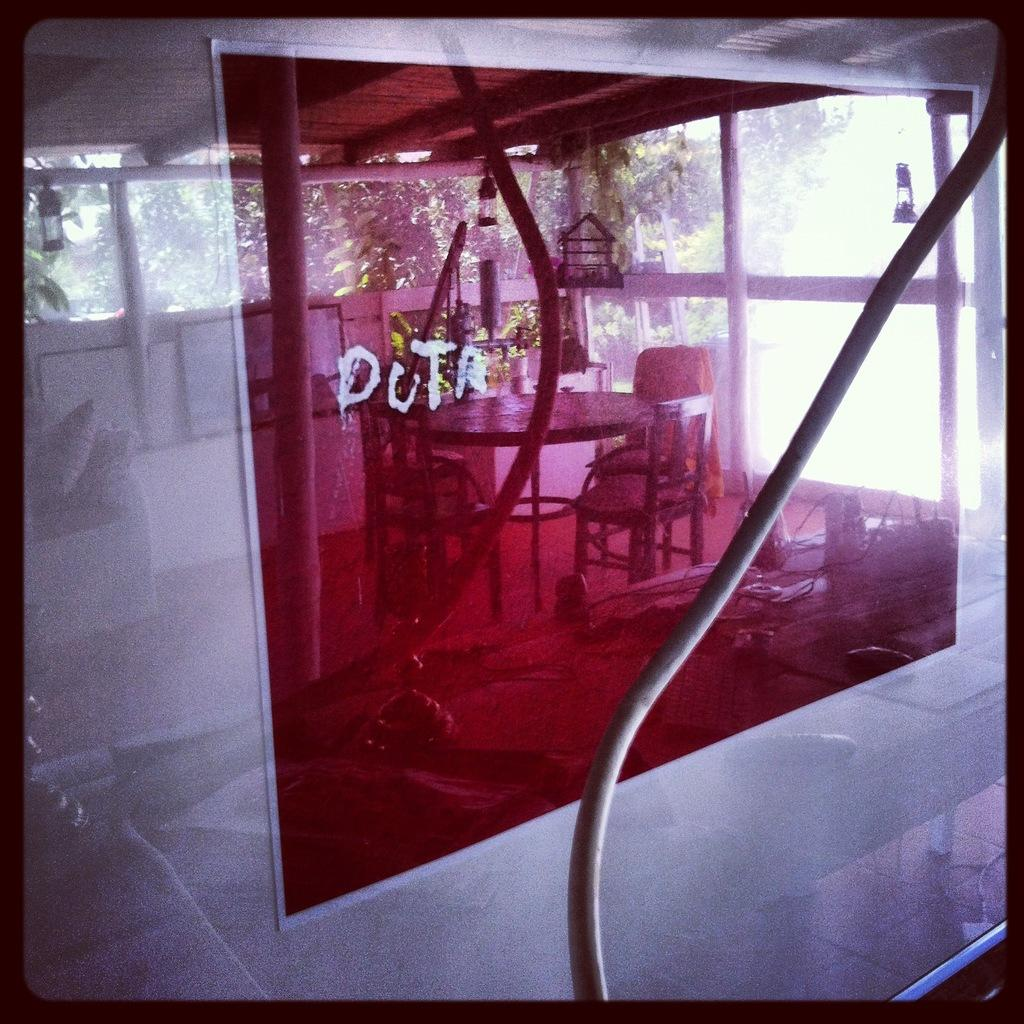What object is present in the image that is made of glass? There is a glass in the image. Can you describe the appearance of the glass? The glass is pink and transparent. What can be seen reflected on the glass? The images of tables and chairs are reflected on the glass. What type of food is being served on the stem in the image? There is no stem or food present in the image; it only features a pink and transparent glass with reflections of tables and chairs. 